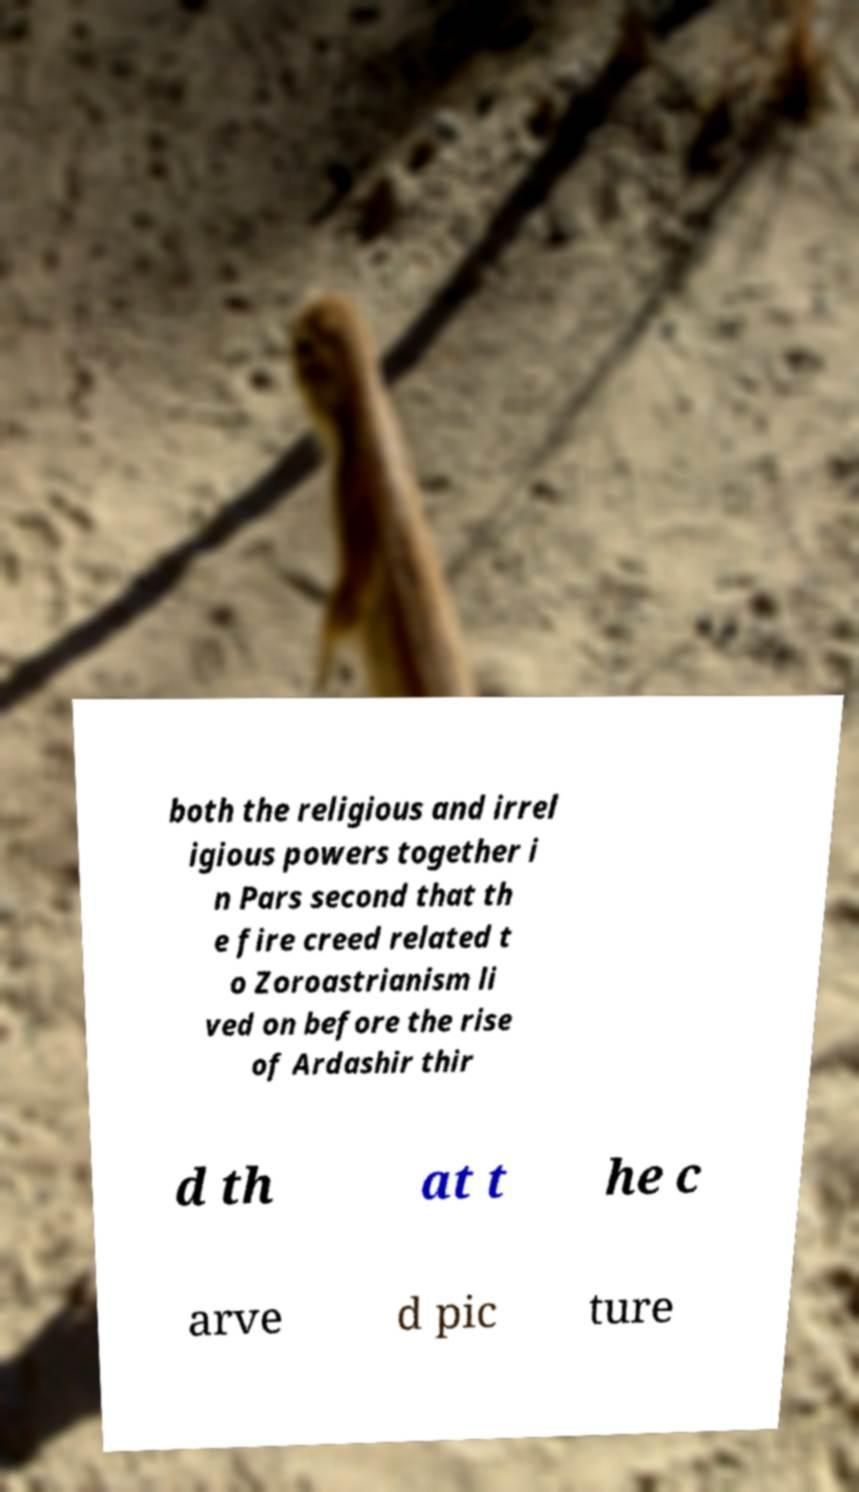Can you read and provide the text displayed in the image?This photo seems to have some interesting text. Can you extract and type it out for me? both the religious and irrel igious powers together i n Pars second that th e fire creed related t o Zoroastrianism li ved on before the rise of Ardashir thir d th at t he c arve d pic ture 